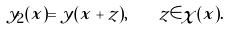Convert formula to latex. <formula><loc_0><loc_0><loc_500><loc_500>y _ { 2 } ( x ) = y ( x + z ) , \quad z \in \chi ( x ) .</formula> 